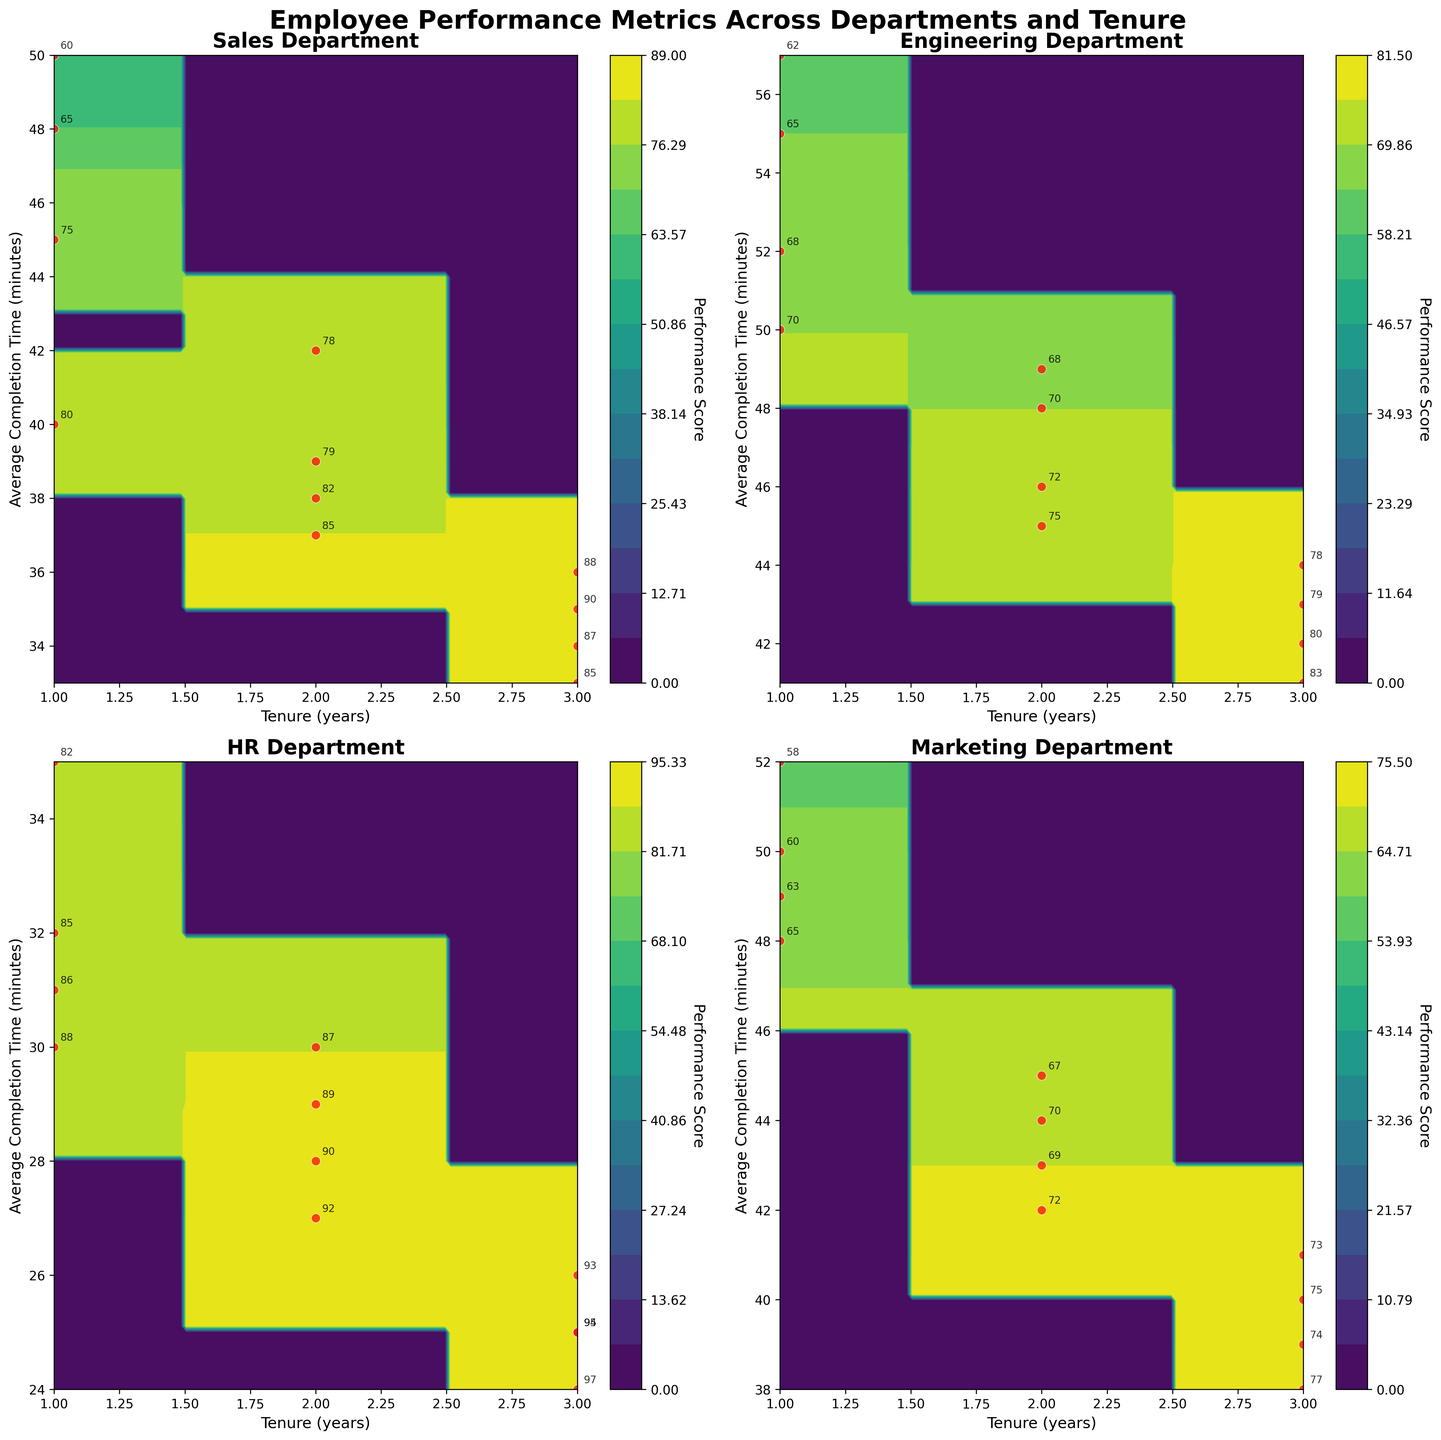What is the title of the figure? The title can be found at the top of the figure. It reads "Employee Performance Metrics Across Departments and Tenure".
Answer: Employee Performance Metrics Across Departments and Tenure Which department has the highest performance score for employees with 3 years of tenure? By looking at the 3-year tenure level across the different departments, we see that HR has the highest performance scores, with values reaching up to 97.
Answer: HR How do completion times differ for HR employees with varying tenures? Examining the HR subplot, the completion times decrease as tenure increases. For instance, 1-year tenure averages around 31 minutes while 3-year tenure hovers around 25 minutes.
Answer: Decrease What range of performance scores can be observed for Sales department employees? By looking at the contours and scatter plots in the Sales department subplot, performance scores range from 60 to 90.
Answer: 60 to 90 Which department shows the broadest range of average completion times across all tenures? By observing the Y-axis ranges of each subplot, Engineering has the broadest range of average completion times from around 41 to 57 minutes.
Answer: Engineering How does the performance score change with increasing tenure in the Marketing department? By examining the contour lines and scatter plots, we can see that performance scores in Marketing generally increase as tenure progresses from 1 to 3 years.
Answer: Increase Compare the average completion time for 2-year tenure between Sales and Engineering departments. Which has the higher value? By comparing the two subplots for tenure = 2 years, we see Sales ranges around 38-42 minutes while Engineering ranges around 45-49 minutes, making Engineering higher.
Answer: Engineering In which department does the increase in tenure correlate most strongly with an increase in performance score? Observing the overall trend in the contour lines, HR shows a strong positive correlation between increased tenure and performance score, more clearly than in other departments.
Answer: HR What performance score would you expect for an Engineering employee with 2 years of tenure and around 47 minutes average completion time? In the Engineering subplot, under the tenure = 2 years line and around 47 minutes of completion time, the contours map to approximately a 70-72 performance score.
Answer: 70-72 Which department shows less variability in performance scores over the tenure of 1 to 3 years? Observing the tight clustering of performance scores within the HR subplot, it shows less variability in performance scores compared to other departments like Sales or Engineering.
Answer: HR 